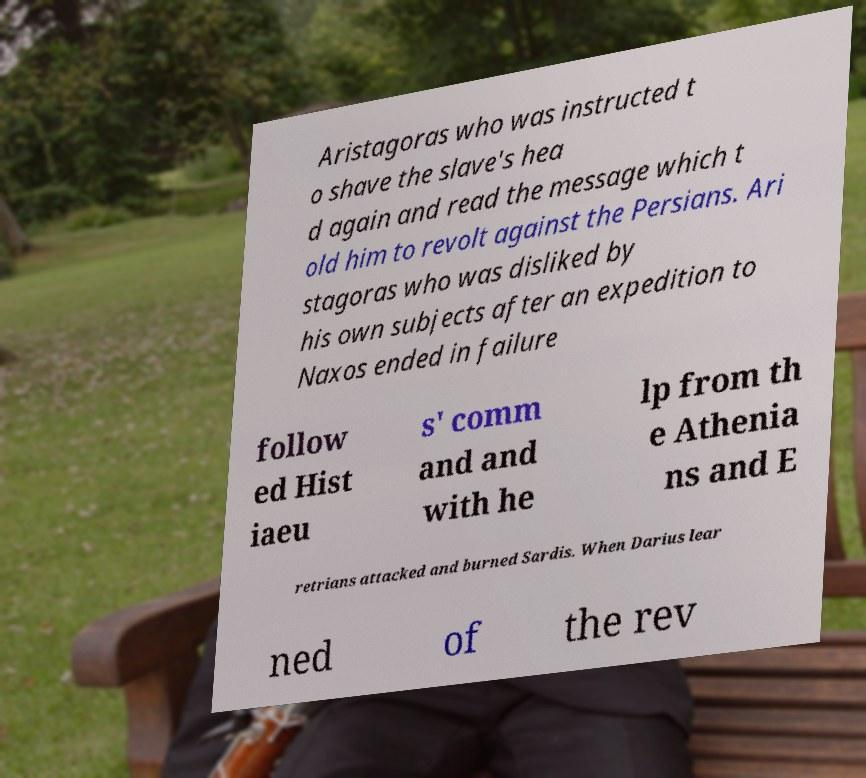Please identify and transcribe the text found in this image. Aristagoras who was instructed t o shave the slave's hea d again and read the message which t old him to revolt against the Persians. Ari stagoras who was disliked by his own subjects after an expedition to Naxos ended in failure follow ed Hist iaeu s' comm and and with he lp from th e Athenia ns and E retrians attacked and burned Sardis. When Darius lear ned of the rev 